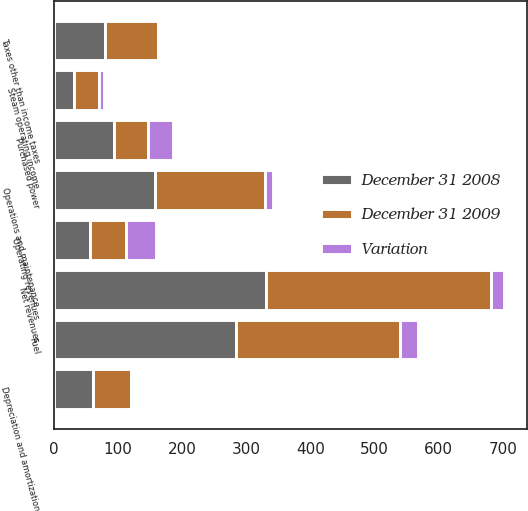<chart> <loc_0><loc_0><loc_500><loc_500><stacked_bar_chart><ecel><fcel>Operating revenues<fcel>Purchased power<fcel>Fuel<fcel>Net revenues<fcel>Operations and maintenance<fcel>Depreciation and amortization<fcel>Taxes other than income taxes<fcel>Steam operating income<nl><fcel>December 31 2009<fcel>56.5<fcel>54<fcel>256<fcel>351<fcel>171<fcel>59<fcel>82<fcel>39<nl><fcel>December 31 2008<fcel>56.5<fcel>93<fcel>284<fcel>330<fcel>158<fcel>61<fcel>80<fcel>31<nl><fcel>Variation<fcel>46<fcel>39<fcel>28<fcel>21<fcel>13<fcel>2<fcel>2<fcel>8<nl></chart> 